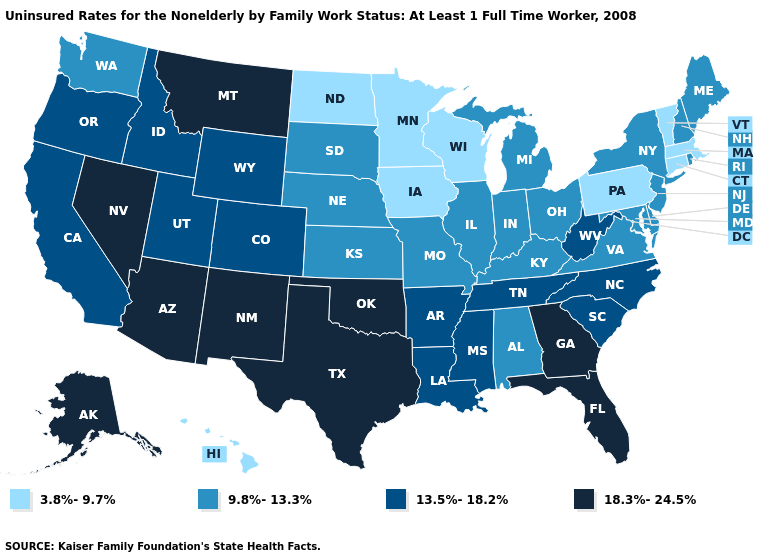Which states have the lowest value in the Northeast?
Quick response, please. Connecticut, Massachusetts, Pennsylvania, Vermont. Name the states that have a value in the range 9.8%-13.3%?
Give a very brief answer. Alabama, Delaware, Illinois, Indiana, Kansas, Kentucky, Maine, Maryland, Michigan, Missouri, Nebraska, New Hampshire, New Jersey, New York, Ohio, Rhode Island, South Dakota, Virginia, Washington. Name the states that have a value in the range 3.8%-9.7%?
Give a very brief answer. Connecticut, Hawaii, Iowa, Massachusetts, Minnesota, North Dakota, Pennsylvania, Vermont, Wisconsin. Does the first symbol in the legend represent the smallest category?
Write a very short answer. Yes. Name the states that have a value in the range 9.8%-13.3%?
Be succinct. Alabama, Delaware, Illinois, Indiana, Kansas, Kentucky, Maine, Maryland, Michigan, Missouri, Nebraska, New Hampshire, New Jersey, New York, Ohio, Rhode Island, South Dakota, Virginia, Washington. Among the states that border North Carolina , does Georgia have the highest value?
Answer briefly. Yes. Among the states that border Virginia , does West Virginia have the lowest value?
Concise answer only. No. Name the states that have a value in the range 13.5%-18.2%?
Quick response, please. Arkansas, California, Colorado, Idaho, Louisiana, Mississippi, North Carolina, Oregon, South Carolina, Tennessee, Utah, West Virginia, Wyoming. Among the states that border Massachusetts , which have the highest value?
Keep it brief. New Hampshire, New York, Rhode Island. Does Ohio have a lower value than New Mexico?
Concise answer only. Yes. What is the value of Georgia?
Give a very brief answer. 18.3%-24.5%. What is the value of Idaho?
Keep it brief. 13.5%-18.2%. What is the value of Washington?
Quick response, please. 9.8%-13.3%. Name the states that have a value in the range 3.8%-9.7%?
Answer briefly. Connecticut, Hawaii, Iowa, Massachusetts, Minnesota, North Dakota, Pennsylvania, Vermont, Wisconsin. Name the states that have a value in the range 18.3%-24.5%?
Keep it brief. Alaska, Arizona, Florida, Georgia, Montana, Nevada, New Mexico, Oklahoma, Texas. 